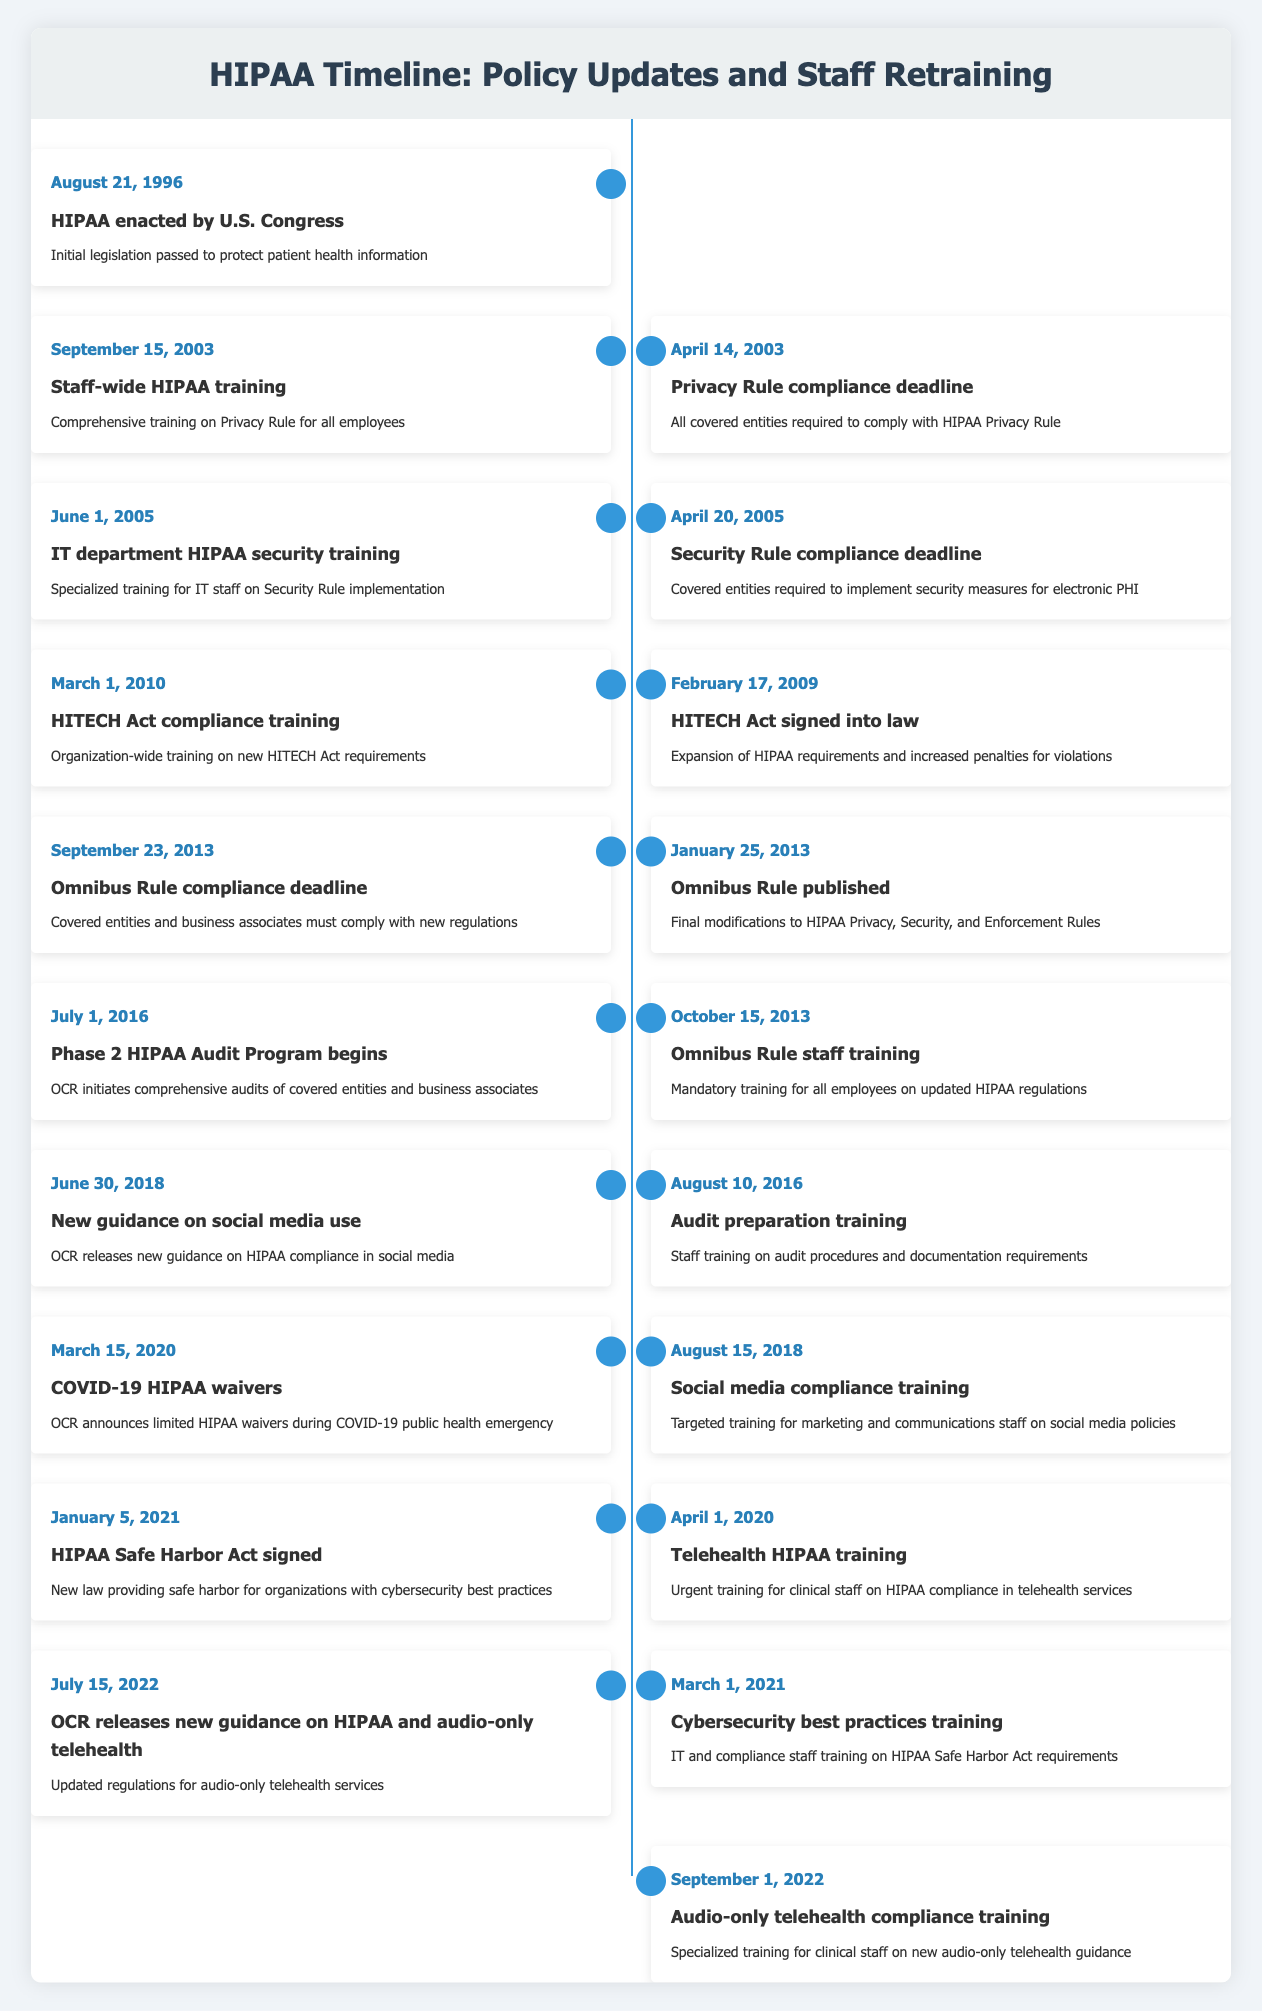What significant legislation was enacted on August 21, 1996? The table indicates that the "HIPAA enacted by U.S. Congress" on that date was the key event. This entry describes the event as the initial legislation passed to protect patient health information.
Answer: HIPAA enacted by U.S. Congress When was the Privacy Rule compliance deadline, and what was its significance? According to the table, the Privacy Rule compliance deadline was on April 14, 2003. This was significant as it mandated that all covered entities needed to comply with the HIPAA Privacy Rule, as mentioned in the event description.
Answer: April 14, 2003; significant for compliance How many years passed between the enactment of HIPAA and the publication of the Omnibus Rule? The HIPAA was enacted in 1996 and the Omnibus Rule was published in 2013. Calculating the difference gives us 2013 - 1996 = 17 years.
Answer: 17 years Was there a training session related to the HITECH Act, and if so, when did it occur? Yes, the table shows that there was "HITECH Act compliance training" held on March 1, 2010. This indicates that the organization emphasized the need for training regarding this new piece of legislation.
Answer: Yes, March 1, 2010 Which training focused on the use of social media, and when did it take place? The table notes a "Social media compliance training" event on August 15, 2018, specifically designed for marketing and communications staff, thus addressing HIPAA compliance in social media usage.
Answer: Social media compliance training, August 15, 2018 What event confirmed the start of the Phase 2 HIPAA Audit Program, and when did it begin? The "Phase 2 HIPAA Audit Program begins" event is listed as starting on July 1, 2016, according to the table. This detail indicates a significant step in the enforcement of HIPAA regulations through audits.
Answer: July 1, 2016 How many compliance training sessions happened after the implementation of the Omnibus Rule? After the "Omnibus Rule" published on January 25, 2013, two training sessions took place: the "Omnibus Rule staff training" on October 15, 2013, and the "Cybersecurity best practices training" on March 1, 2021, totaling two training sessions.
Answer: Two training sessions What is the nature of the updates related to audio-only telehealth, and when was the guidance released? The timeline includes an entry for "OCR releases new guidance on HIPAA and audio-only telehealth" on July 15, 2022, indicating a focus on updated regulations for this service type, thereby ensuring compliance in a new healthcare delivery method.
Answer: Updated guidance released on July 15, 2022 